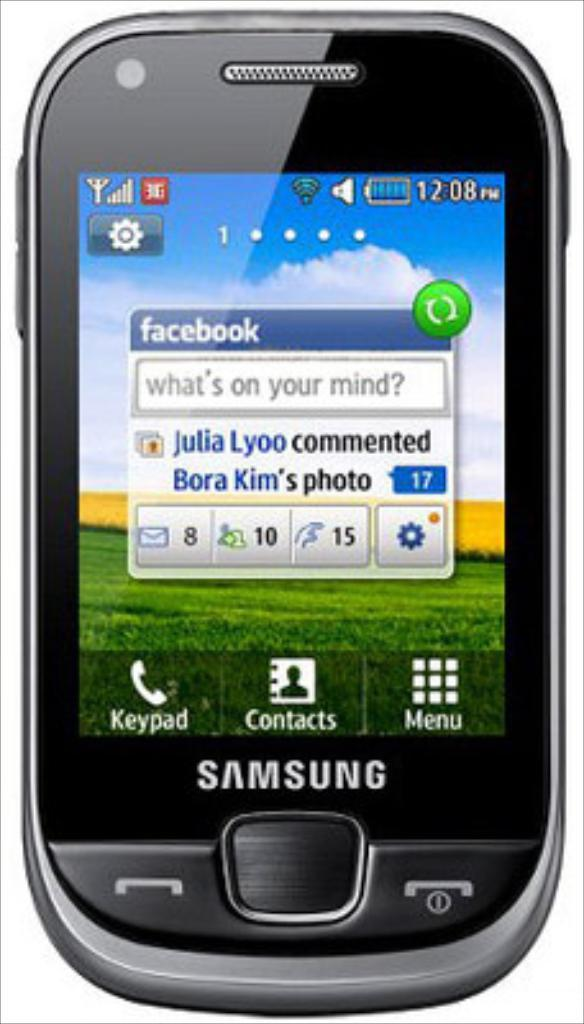Provide a one-sentence caption for the provided image. A black Samsung phone is against a white backdrop. 